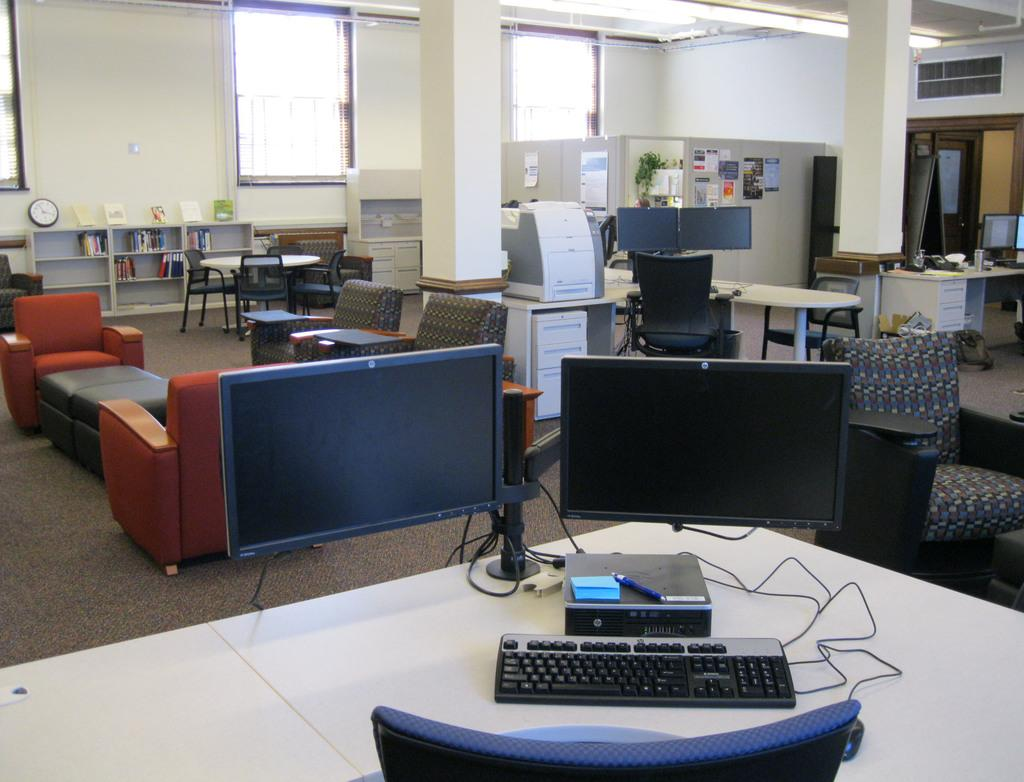What is the main object in the center of the image? There is a table in the center of the image. What is placed on the table? Monitors are present on the table, along with other objects. Can you describe the background of the image? In the background, there is a sofa, chairs, at least one table, a pillar, a wall, books, and a clock. Is there any quicksand visible in the image? No, there is no quicksand present in the image. What town is depicted in the image? The image does not depict a town; it shows a room with a table, monitors, and other objects. 